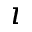Convert formula to latex. <formula><loc_0><loc_0><loc_500><loc_500>\imath</formula> 